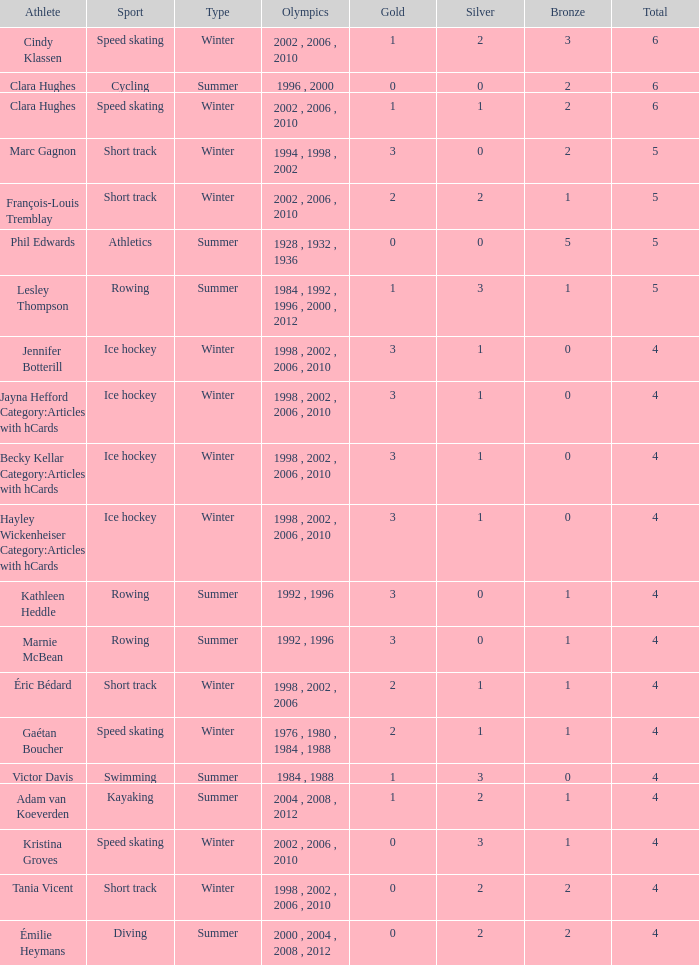What is the mean gold for a winter athlete who has 1 bronze, fewer than 3 silver medals, and a total of less than 4 medals? None. 